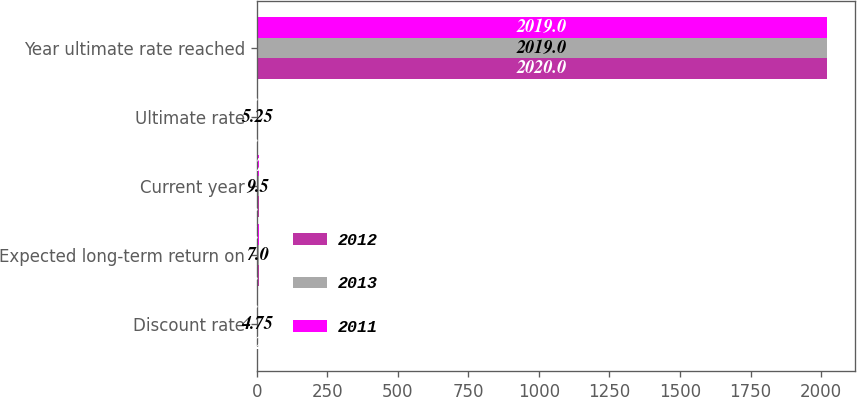<chart> <loc_0><loc_0><loc_500><loc_500><stacked_bar_chart><ecel><fcel>Discount rate<fcel>Expected long-term return on<fcel>Current year<fcel>Ultimate rate<fcel>Year ultimate rate reached<nl><fcel>2012<fcel>4.25<fcel>6.7<fcel>8.5<fcel>5<fcel>2020<nl><fcel>2013<fcel>4.75<fcel>7<fcel>9.5<fcel>5.25<fcel>2019<nl><fcel>2011<fcel>5.5<fcel>7<fcel>9.75<fcel>5.5<fcel>2019<nl></chart> 